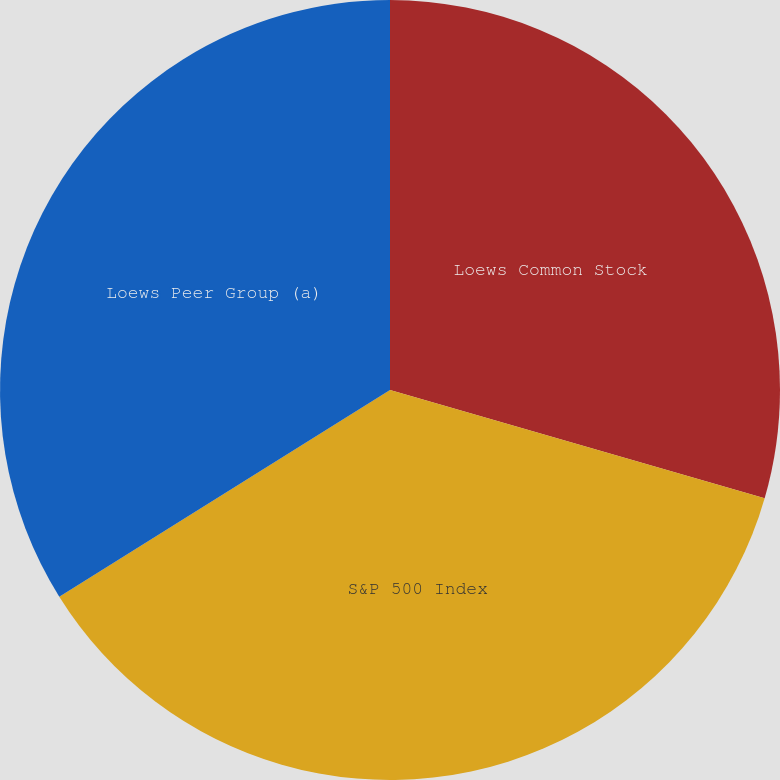Convert chart. <chart><loc_0><loc_0><loc_500><loc_500><pie_chart><fcel>Loews Common Stock<fcel>S&P 500 Index<fcel>Loews Peer Group (a)<nl><fcel>29.48%<fcel>36.63%<fcel>33.89%<nl></chart> 